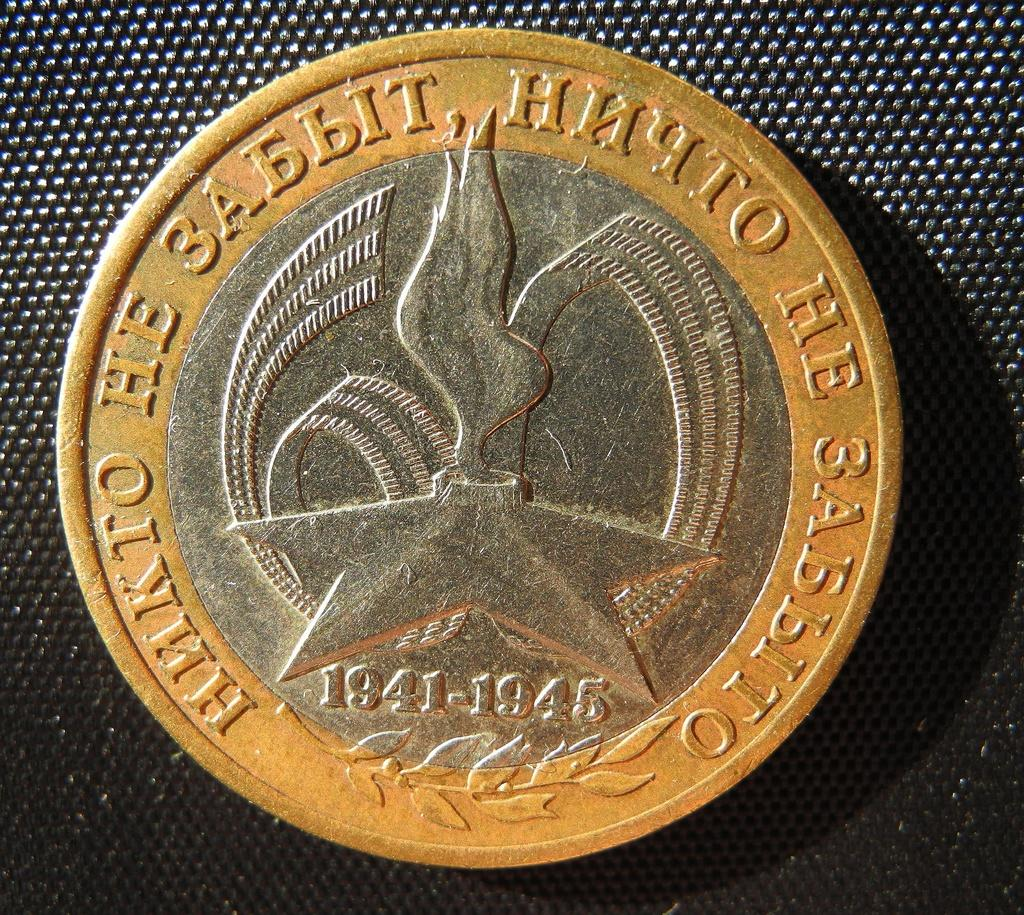<image>
Give a short and clear explanation of the subsequent image. A coin from 1941-1945 with foreign inscription on it 